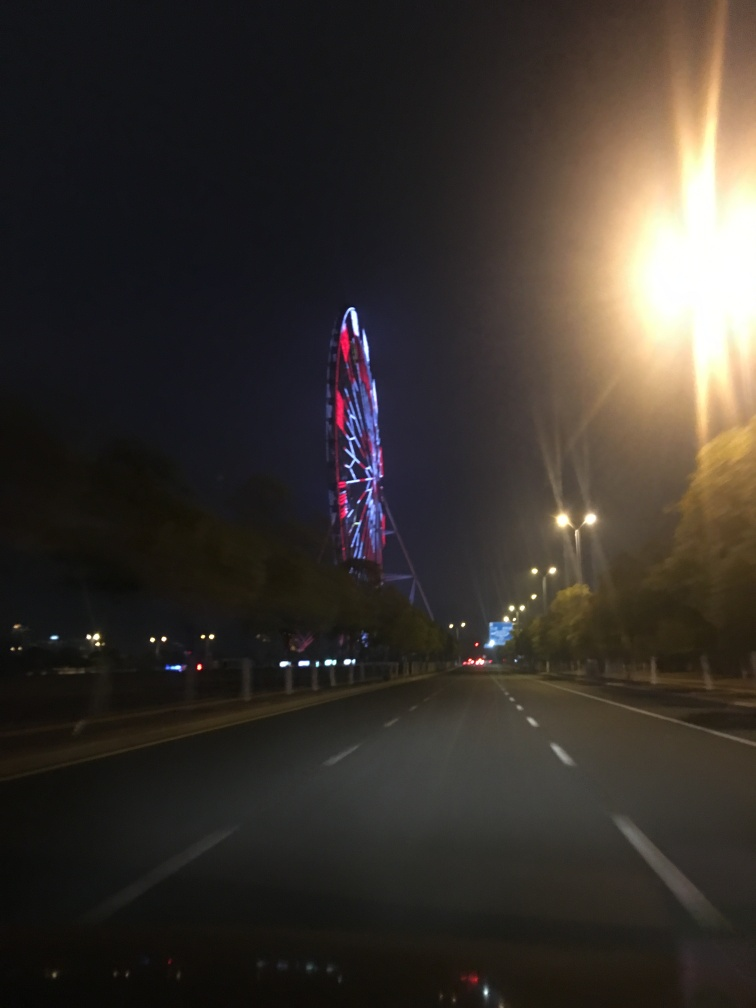What can be inferred about the location of the image? The presence of the illuminated Ferris wheel suggests that the location might be near an amusement park or a tourist area. Additionally, the image shows a well-maintained road with multiple lanes, indicating it could be within a city or a developed urban area. 